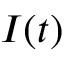Convert formula to latex. <formula><loc_0><loc_0><loc_500><loc_500>I ( t )</formula> 